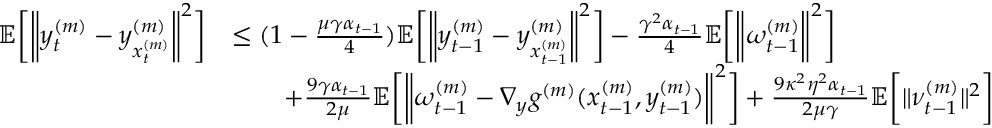<formula> <loc_0><loc_0><loc_500><loc_500>\begin{array} { r l } { \mathbb { E } \left [ \left \| y _ { t } ^ { ( m ) } - y _ { x _ { t } ^ { ( m ) } } ^ { ( m ) } \right \| ^ { 2 } \right ] } & { \leq ( 1 - \frac { \mu \gamma \alpha _ { t - 1 } } { 4 } ) \mathbb { E } \left [ \left \| y _ { t - 1 } ^ { ( m ) } - y _ { x _ { t - 1 } ^ { ( m ) } } ^ { ( m ) } \right \| ^ { 2 } \right ] - \frac { \gamma ^ { 2 } \alpha _ { t - 1 } } { 4 } \mathbb { E } \left [ \left \| \omega _ { t - 1 } ^ { ( m ) } \right \| ^ { 2 } \right ] } \\ & { \quad + \frac { 9 \gamma \alpha _ { t - 1 } } { 2 \mu } \mathbb { E } \left [ \left \| \omega _ { t - 1 } ^ { ( m ) } - \nabla _ { y } g ^ { ( m ) } ( x _ { t - 1 } ^ { ( m ) } , y _ { t - 1 } ^ { ( m ) } ) \right \| ^ { 2 } \right ] + \frac { 9 \kappa ^ { 2 } \eta ^ { 2 } \alpha _ { t - 1 } } { 2 \mu \gamma } \mathbb { E } \left [ \| \nu _ { t - 1 } ^ { ( m ) } \| ^ { 2 } \right ] } \end{array}</formula> 